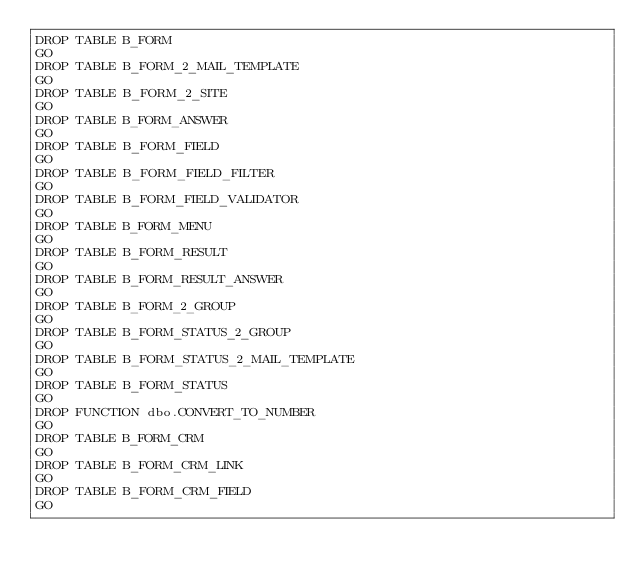<code> <loc_0><loc_0><loc_500><loc_500><_SQL_>DROP TABLE B_FORM
GO
DROP TABLE B_FORM_2_MAIL_TEMPLATE
GO
DROP TABLE B_FORM_2_SITE
GO
DROP TABLE B_FORM_ANSWER
GO
DROP TABLE B_FORM_FIELD
GO
DROP TABLE B_FORM_FIELD_FILTER
GO
DROP TABLE B_FORM_FIELD_VALIDATOR
GO
DROP TABLE B_FORM_MENU
GO
DROP TABLE B_FORM_RESULT
GO
DROP TABLE B_FORM_RESULT_ANSWER
GO
DROP TABLE B_FORM_2_GROUP
GO
DROP TABLE B_FORM_STATUS_2_GROUP
GO
DROP TABLE B_FORM_STATUS_2_MAIL_TEMPLATE
GO
DROP TABLE B_FORM_STATUS
GO
DROP FUNCTION dbo.CONVERT_TO_NUMBER
GO
DROP TABLE B_FORM_CRM
GO
DROP TABLE B_FORM_CRM_LINK
GO
DROP TABLE B_FORM_CRM_FIELD
GO</code> 